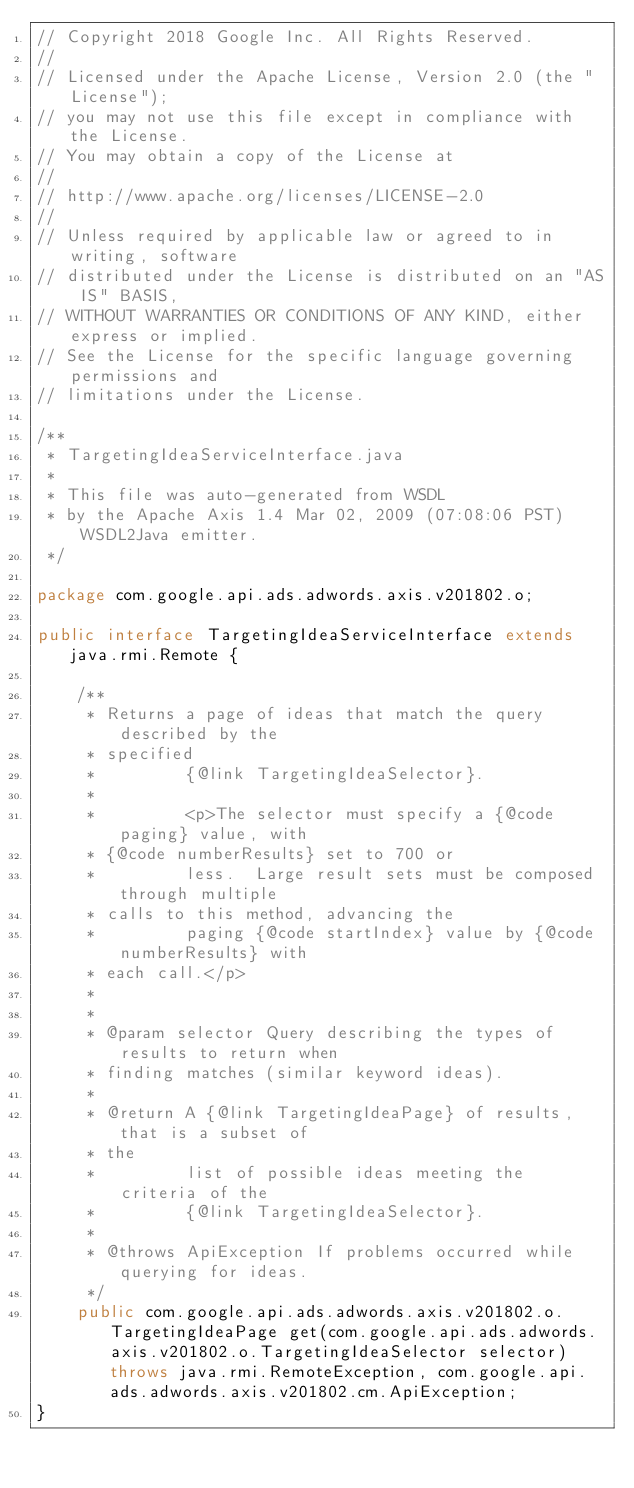Convert code to text. <code><loc_0><loc_0><loc_500><loc_500><_Java_>// Copyright 2018 Google Inc. All Rights Reserved.
//
// Licensed under the Apache License, Version 2.0 (the "License");
// you may not use this file except in compliance with the License.
// You may obtain a copy of the License at
//
// http://www.apache.org/licenses/LICENSE-2.0
//
// Unless required by applicable law or agreed to in writing, software
// distributed under the License is distributed on an "AS IS" BASIS,
// WITHOUT WARRANTIES OR CONDITIONS OF ANY KIND, either express or implied.
// See the License for the specific language governing permissions and
// limitations under the License.

/**
 * TargetingIdeaServiceInterface.java
 *
 * This file was auto-generated from WSDL
 * by the Apache Axis 1.4 Mar 02, 2009 (07:08:06 PST) WSDL2Java emitter.
 */

package com.google.api.ads.adwords.axis.v201802.o;

public interface TargetingIdeaServiceInterface extends java.rmi.Remote {

    /**
     * Returns a page of ideas that match the query described by the
     * specified
     *         {@link TargetingIdeaSelector}.
     *         
     *         <p>The selector must specify a {@code paging} value, with
     * {@code numberResults} set to 700 or
     *         less.  Large result sets must be composed through multiple
     * calls to this method, advancing the
     *         paging {@code startIndex} value by {@code numberResults} with
     * each call.</p>
     *         
     *         
     * @param selector Query describing the types of results to return when
     * finding matches (similar keyword ideas).
     *         
     * @return A {@link TargetingIdeaPage} of results, that is a subset of
     * the
     *         list of possible ideas meeting the criteria of the
     *         {@link TargetingIdeaSelector}.
     *         
     * @throws ApiException If problems occurred while querying for ideas.
     */
    public com.google.api.ads.adwords.axis.v201802.o.TargetingIdeaPage get(com.google.api.ads.adwords.axis.v201802.o.TargetingIdeaSelector selector) throws java.rmi.RemoteException, com.google.api.ads.adwords.axis.v201802.cm.ApiException;
}
</code> 